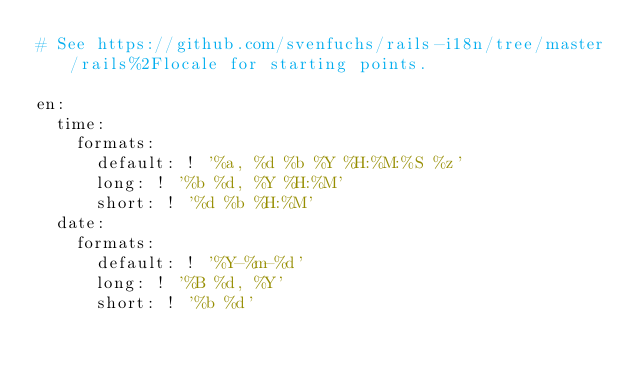Convert code to text. <code><loc_0><loc_0><loc_500><loc_500><_YAML_># See https://github.com/svenfuchs/rails-i18n/tree/master/rails%2Flocale for starting points.

en:
  time:
    formats:
      default: ! '%a, %d %b %Y %H:%M:%S %z'
      long: ! '%b %d, %Y %H:%M'
      short: ! '%d %b %H:%M'
  date:
    formats:
      default: ! '%Y-%m-%d'
      long: ! '%B %d, %Y'
      short: ! '%b %d'
</code> 